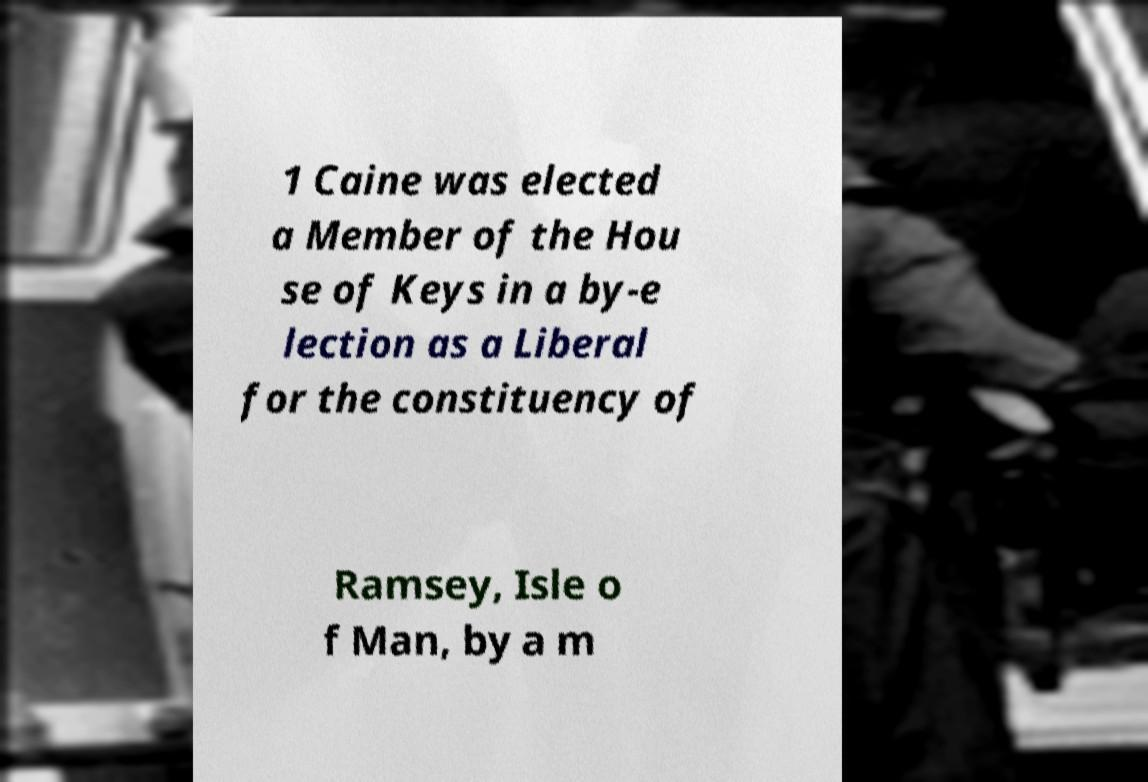For documentation purposes, I need the text within this image transcribed. Could you provide that? 1 Caine was elected a Member of the Hou se of Keys in a by-e lection as a Liberal for the constituency of Ramsey, Isle o f Man, by a m 